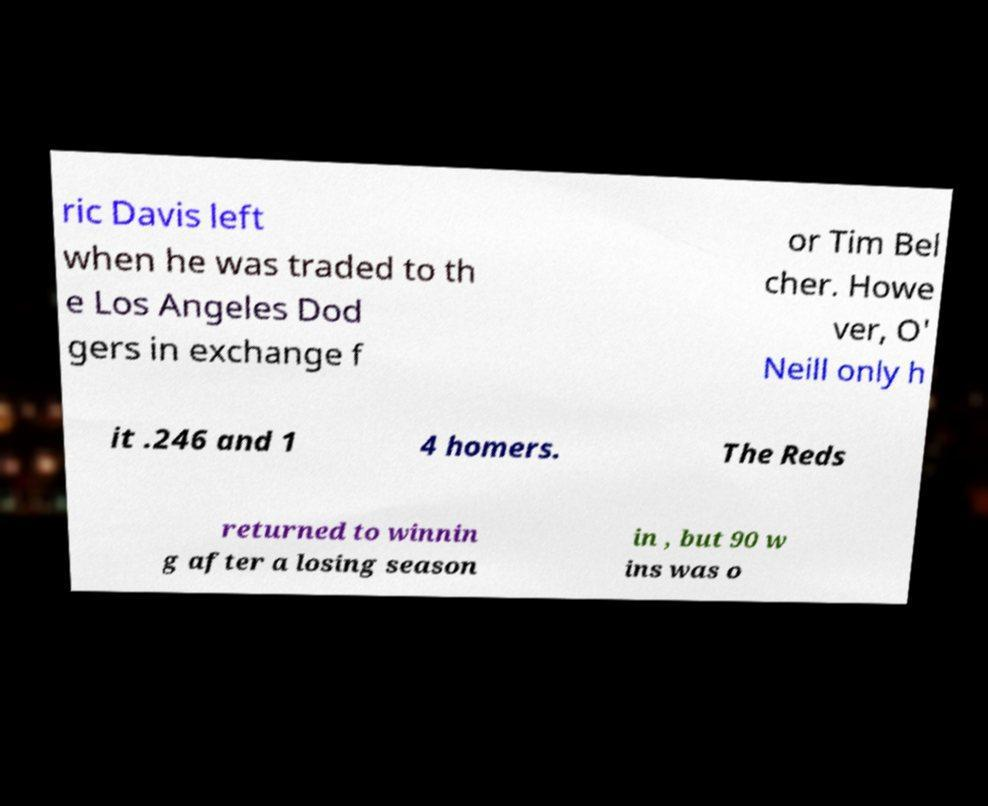There's text embedded in this image that I need extracted. Can you transcribe it verbatim? ric Davis left when he was traded to th e Los Angeles Dod gers in exchange f or Tim Bel cher. Howe ver, O' Neill only h it .246 and 1 4 homers. The Reds returned to winnin g after a losing season in , but 90 w ins was o 